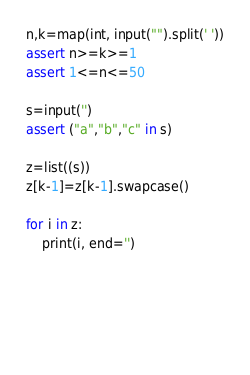Convert code to text. <code><loc_0><loc_0><loc_500><loc_500><_Python_>n,k=map(int, input("").split(' '))
assert n>=k>=1
assert 1<=n<=50

s=input('')
assert ("a","b","c" in s)

z=list((s))
z[k-1]=z[k-1].swapcase()

for i in z:
    print(i, end='')



  
 

</code> 